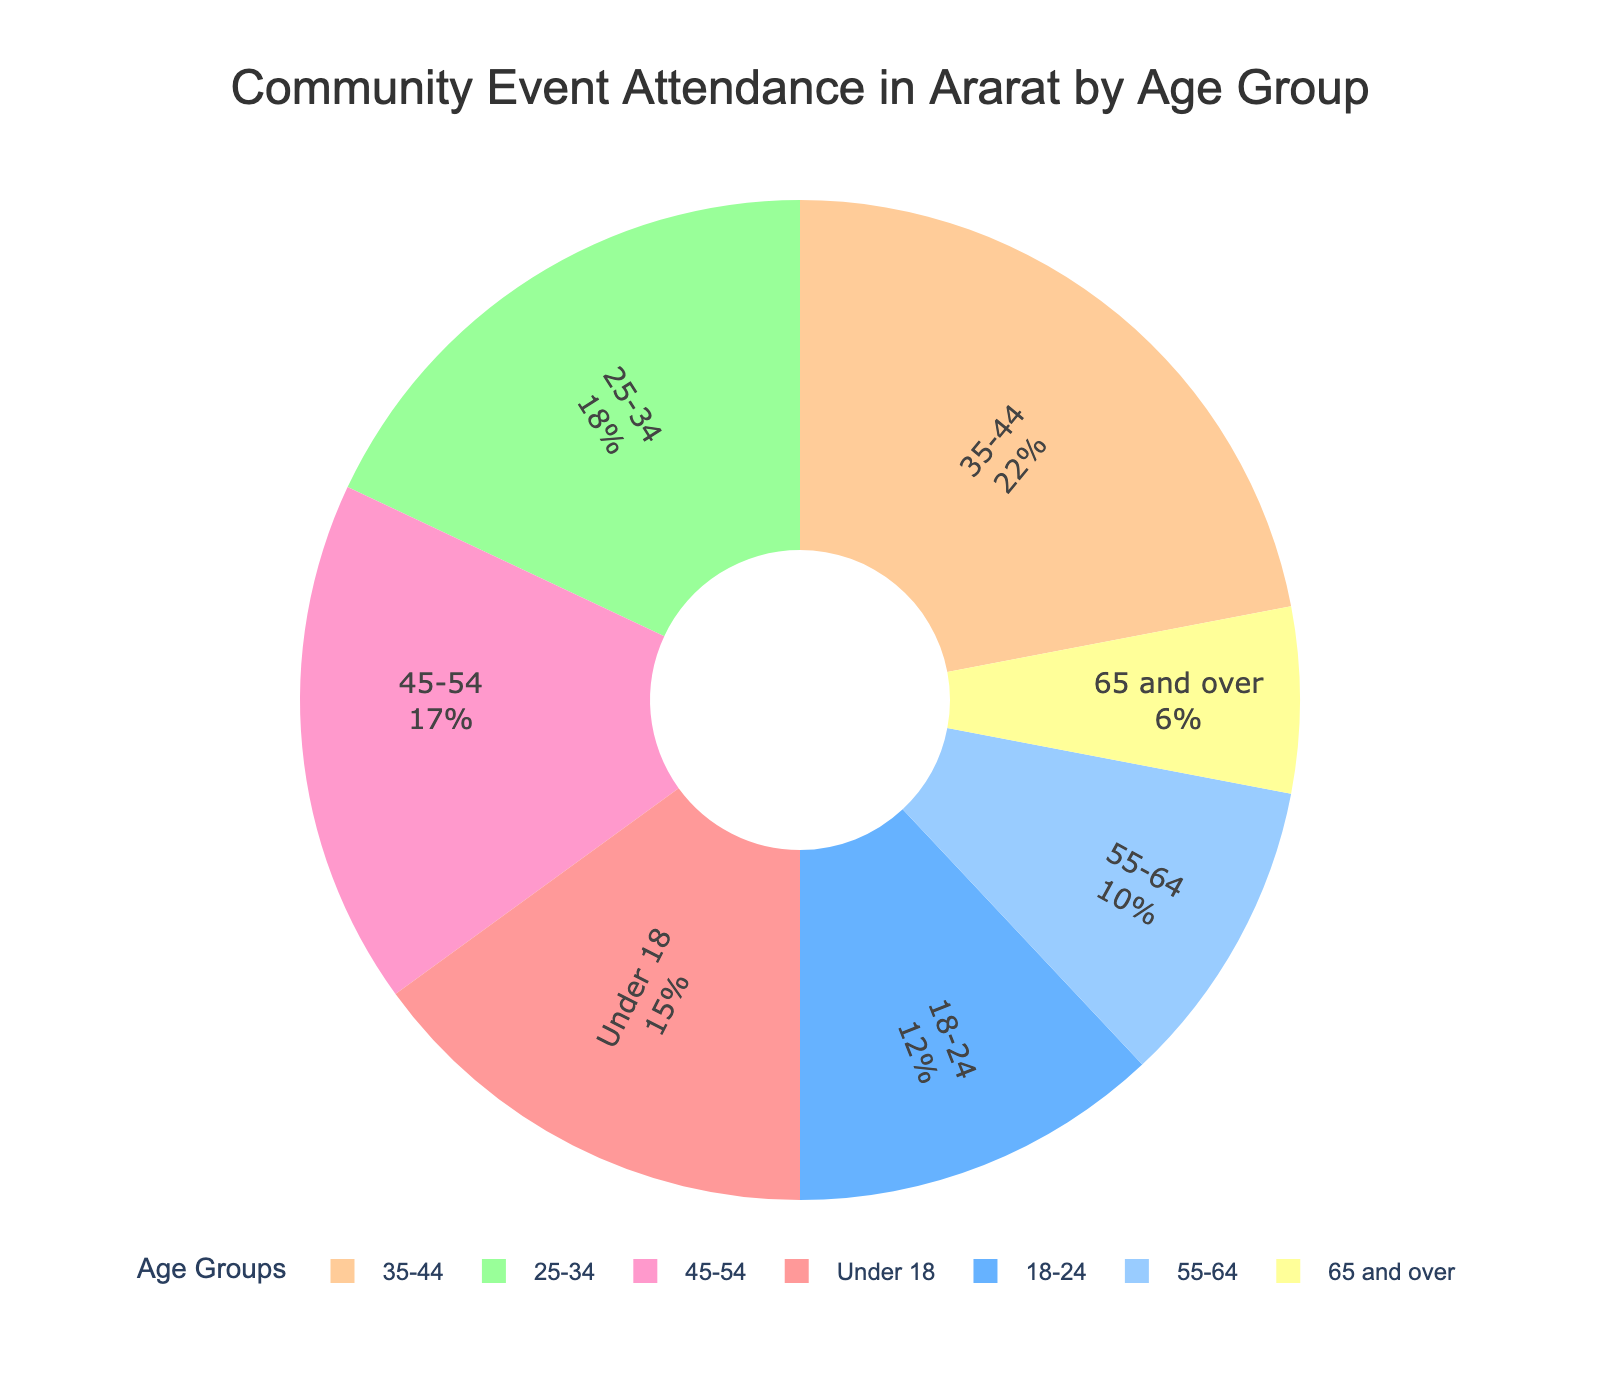Which age group has the highest attendance percentage? The pie chart shows the percentage of attendance for different age groups. The largest segment represents the age group with the highest attendance.
Answer: 35-44 Which age group has the lowest attendance percentage? The pie chart displays each age group's attendance percentage. The smallest segment corresponds to the age group with the lowest attendance.
Answer: 65 and over What are the combined attendance percentages of the age groups under 18 and over 65? Add the attendance percentages of the "Under 18" and "65 and over" age groups from the pie chart. (15% + 6%)
Answer: 21% How does the attendance percentage of the 25-34 age group compare to the 45-54 age group? Compare the attendance percentage of the 25-34 age group (18%) to the 45-54 age group (17%) displayed in the pie chart.
Answer: 25-34 is higher Which two adjacent age groups combined have the highest attendance percentage? Look for two neighboring age slices in the pie chart that sum to the highest value. (35-44 and 45-54 = 22% + 17%)
Answer: 35-44 and 45-54 What is the average attendance percentage of the groups from 18 to 54 years old? Calculate the average of the attendance percentages of the age groups in the range 18 to 54. ((12% + 18% + 22% + 17%) / 4) = 69% / 4
Answer: 17.25% Compare the total attendance percentage of age groups under 35 to those 35 and over. Sum the percentages of age groups under 35 and those 35 and over. (15% + 12% + 18% = 45%) and (22% + 17% + 10% + 6% = 55%)
Answer: Under 35 is lower How much more is the attendance percentage of the 35-44 age group than the 55-64 age group? Subtract the attendance percentage of the 55-64 age group from the 35-44 age group (22% - 10%)
Answer: 12% Which age group's segment in the pie chart is represented by a green color? Identify the color correspondence by visually inspecting the pie chart legend and segments.
Answer: 25-34 